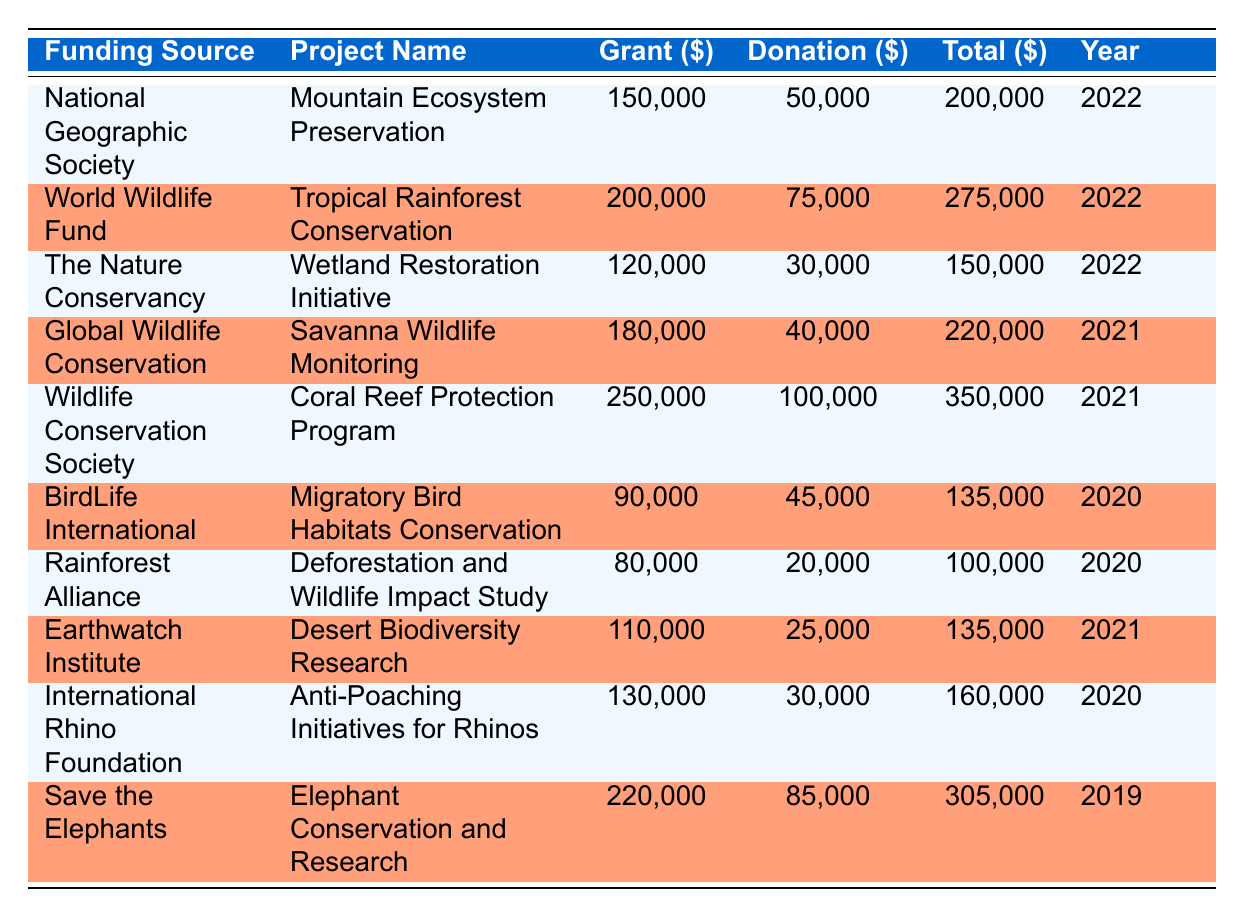What is the total grant amount for the "Coral Reef Protection Program"? The table indicates that the grant amount for the "Coral Reef Protection Program" under the funding source "Wildlife Conservation Society" is 250,000.
Answer: 250,000 What is the year with the highest total funding? To find the year with the highest total funding, we look at the "Total" column. The years and their respective total funds are: 2022 - 200,000; 2022 - 275,000; 2022 - 150,000; 2021 - 220,000; 2021 - 350,000; 2020 - 135,000; 2020 - 100,000; 2021 - 135,000; 2020 - 160,000; 2019 - 305,000. The highest total funding is 350,000 in the year 2021.
Answer: 2021 What is the combined grant amount for all projects in 2022? The projects funded in 2022 and their grant amounts are: Mountain Ecosystem Preservation - 150,000; Tropical Rainforest Conservation - 200,000; Wetland Restoration Initiative - 120,000. Summing these grant amounts gives 150,000 + 200,000 + 120,000 = 470,000.
Answer: 470,000 Is the donation amount for "Anti-Poaching Initiatives for Rhinos" greater than 30,000? According to the table, the donation amount for "Anti-Poaching Initiatives for Rhinos" from the International Rhino Foundation is 30,000. Since 30,000 is not greater than itself, the answer is no.
Answer: No Which project received the highest combined total funds? To determine the project with the highest total funds, we reference the "Total" column. The highest total funds seen in the table is 350,000, associated with the "Coral Reef Protection Program" from the Wildlife Conservation Society.
Answer: Coral Reef Protection Program What is the average donation amount across all projects listed in 2021? The donation amounts for projects in 2021 are: 40,000 (Savanna Wildlife Monitoring), 100,000 (Coral Reef Protection Program), 25,000 (Desert Biodiversity Research). Adding these gives 40,000 + 100,000 + 25,000 = 165,000. There are 3 donation values, hence the average is 165,000 / 3 = 55,000.
Answer: 55,000 Did the "Mountain Ecosystem Preservation" project secure more than 200,000 in total funds? The table shows that the "Mountain Ecosystem Preservation" project has a total of 200,000. Since 200,000 is not more than 200,000, the answer is no.
Answer: No What percentage of the total funds for the "Desert Biodiversity Research" project comes from donations? The total funds for the "Desert Biodiversity Research" project is 135,000, and the donation amount is 25,000. To find the percentage, we calculate (25,000 / 135,000) * 100 ≈ 18.52%.
Answer: 18.52% 